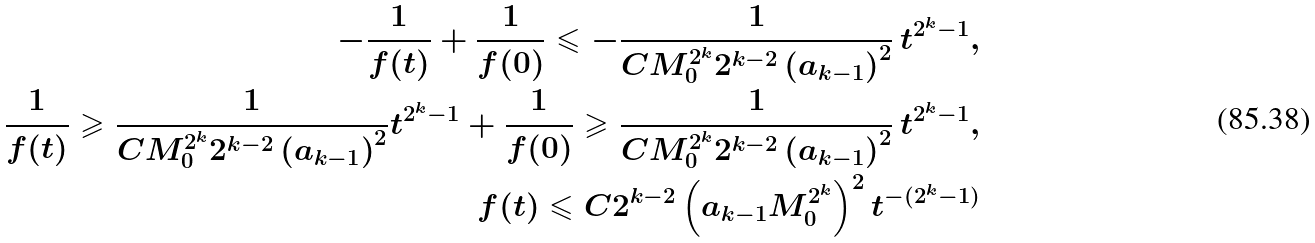<formula> <loc_0><loc_0><loc_500><loc_500>- \frac { 1 } { f ( t ) } + \frac { 1 } { f ( 0 ) } \leqslant - \frac { 1 } { C M _ { 0 } ^ { 2 ^ { k } } 2 ^ { k - 2 } \left ( a _ { k - 1 } \right ) ^ { 2 } } \, t ^ { 2 ^ { k } - 1 } , \\ \frac { 1 } { f ( t ) } \geqslant \frac { 1 } { C M _ { 0 } ^ { 2 ^ { k } } 2 ^ { k - 2 } \left ( a _ { k - 1 } \right ) ^ { 2 } } t ^ { 2 ^ { k } - 1 } + \frac { 1 } { f ( 0 ) } \geqslant \frac { 1 } { C M _ { 0 } ^ { 2 ^ { k } } 2 ^ { k - 2 } \left ( a _ { k - 1 } \right ) ^ { 2 } } \, t ^ { 2 ^ { k } - 1 } , \\ f ( t ) \leqslant C 2 ^ { k - 2 } \left ( a _ { k - 1 } M _ { 0 } ^ { 2 ^ { k } } \right ) ^ { 2 } t ^ { - ( 2 ^ { k } - 1 ) }</formula> 